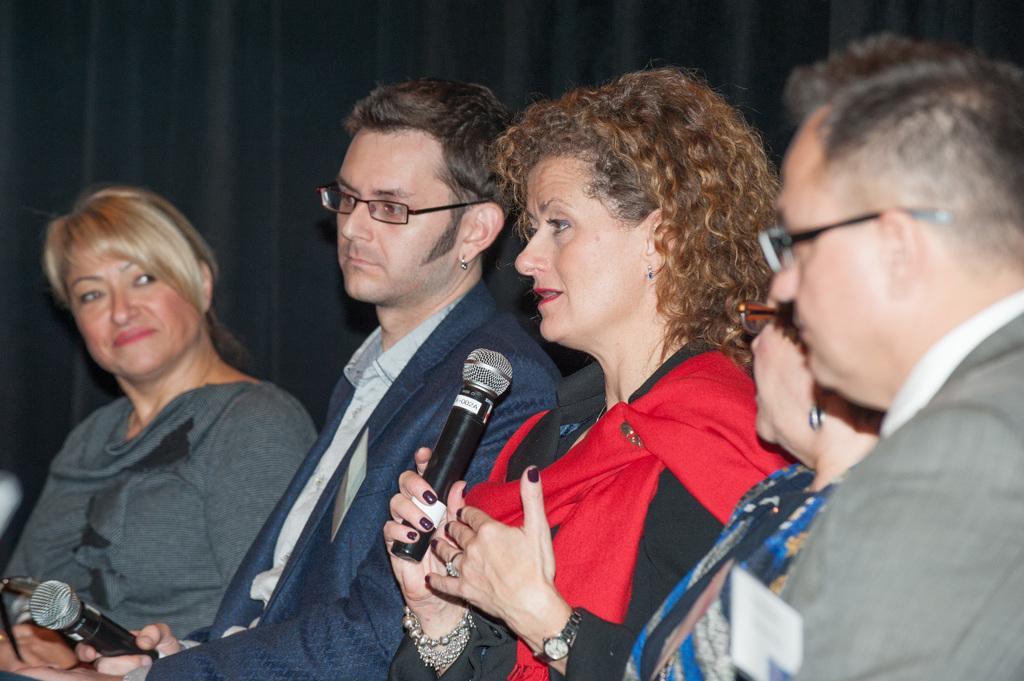Please provide a concise description of this image. There are five persons in different color dresses, sitting. One of them is holding a mic and speaking. And the background is dark in color. 